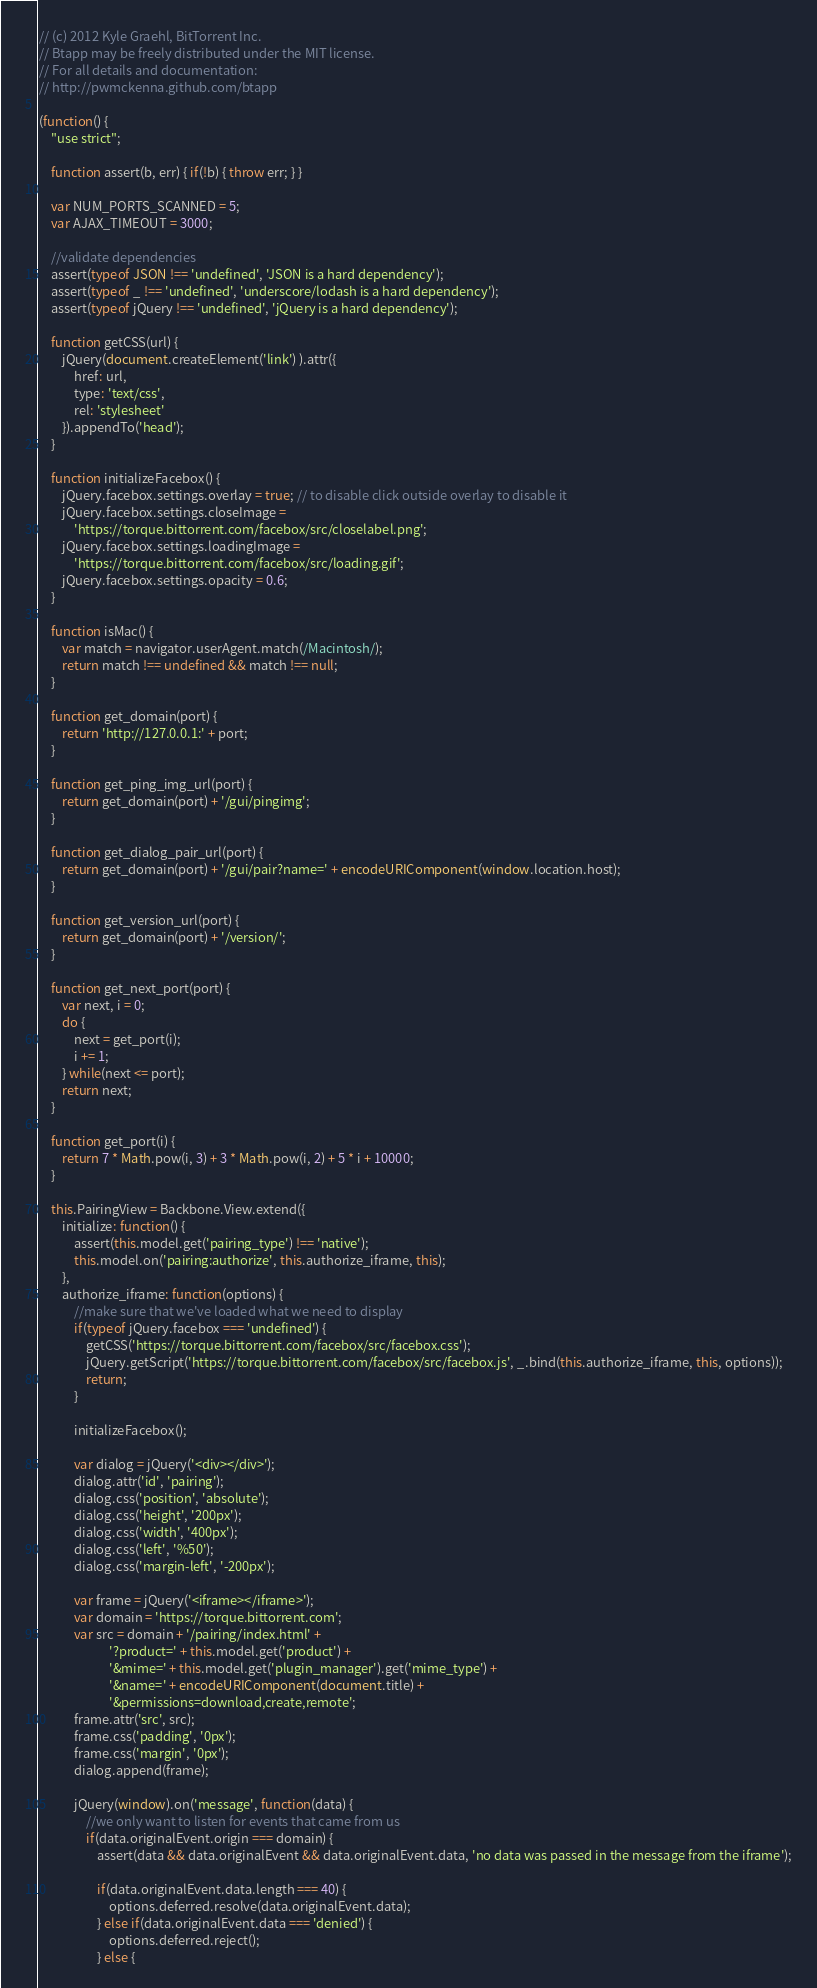<code> <loc_0><loc_0><loc_500><loc_500><_JavaScript_>// (c) 2012 Kyle Graehl, BitTorrent Inc.
// Btapp may be freely distributed under the MIT license.
// For all details and documentation:
// http://pwmckenna.github.com/btapp

(function() {
    "use strict";
    
    function assert(b, err) { if(!b) { throw err; } } 

    var NUM_PORTS_SCANNED = 5;
    var AJAX_TIMEOUT = 3000;

    //validate dependencies
    assert(typeof JSON !== 'undefined', 'JSON is a hard dependency');
    assert(typeof _ !== 'undefined', 'underscore/lodash is a hard dependency');
    assert(typeof jQuery !== 'undefined', 'jQuery is a hard dependency');

    function getCSS(url) {
        jQuery(document.createElement('link') ).attr({
            href: url,
            type: 'text/css',
            rel: 'stylesheet'
        }).appendTo('head');
    }
    
    function initializeFacebox() {
        jQuery.facebox.settings.overlay = true; // to disable click outside overlay to disable it
        jQuery.facebox.settings.closeImage = 
            'https://torque.bittorrent.com/facebox/src/closelabel.png';
        jQuery.facebox.settings.loadingImage = 
            'https://torque.bittorrent.com/facebox/src/loading.gif';                     
        jQuery.facebox.settings.opacity = 0.6;
    }

    function isMac() {
        var match = navigator.userAgent.match(/Macintosh/);
        return match !== undefined && match !== null;
    }

    function get_domain(port) {
        return 'http://127.0.0.1:' + port;
    }

    function get_ping_img_url(port) {
        return get_domain(port) + '/gui/pingimg';
    }
    
    function get_dialog_pair_url(port) {
        return get_domain(port) + '/gui/pair?name=' + encodeURIComponent(window.location.host);
    }

    function get_version_url(port) {
        return get_domain(port) + '/version/';
    }

    function get_next_port(port) {
        var next, i = 0;
        do {
            next = get_port(i);
            i += 1;
        } while(next <= port);
        return next;
    }

    function get_port(i) {
        return 7 * Math.pow(i, 3) + 3 * Math.pow(i, 2) + 5 * i + 10000;
    }

    this.PairingView = Backbone.View.extend({
        initialize: function() {
            assert(this.model.get('pairing_type') !== 'native');
            this.model.on('pairing:authorize', this.authorize_iframe, this);
        },
        authorize_iframe: function(options) {
            //make sure that we've loaded what we need to display
            if(typeof jQuery.facebox === 'undefined') {
                getCSS('https://torque.bittorrent.com/facebox/src/facebox.css');
                jQuery.getScript('https://torque.bittorrent.com/facebox/src/facebox.js', _.bind(this.authorize_iframe, this, options));
                return;
            }

            initializeFacebox();

            var dialog = jQuery('<div></div>');
            dialog.attr('id', 'pairing');
            dialog.css('position', 'absolute');
            dialog.css('height', '200px');
            dialog.css('width', '400px');
            dialog.css('left', '%50');
            dialog.css('margin-left', '-200px');

            var frame = jQuery('<iframe></iframe>');
            var domain = 'https://torque.bittorrent.com';
            var src = domain + '/pairing/index.html' + 
                        '?product=' + this.model.get('product') +
                        '&mime=' + this.model.get('plugin_manager').get('mime_type') +
                        '&name=' + encodeURIComponent(document.title) +
                        '&permissions=download,create,remote';
            frame.attr('src', src);
            frame.css('padding', '0px');
            frame.css('margin', '0px');
            dialog.append(frame);

            jQuery(window).on('message', function(data) {
                //we only want to listen for events that came from us
                if(data.originalEvent.origin === domain) {
                    assert(data && data.originalEvent && data.originalEvent.data, 'no data was passed in the message from the iframe');

                    if(data.originalEvent.data.length === 40) {
                        options.deferred.resolve(data.originalEvent.data);
                    } else if(data.originalEvent.data === 'denied') {
                        options.deferred.reject();
                    } else {</code> 